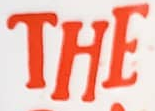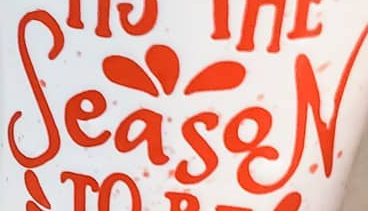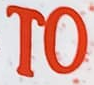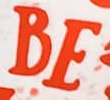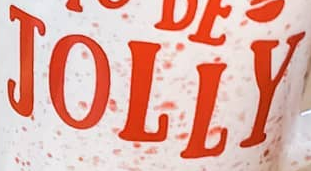What text appears in these images from left to right, separated by a semicolon? THE; SeasoN; TO; BE; JOLLY 